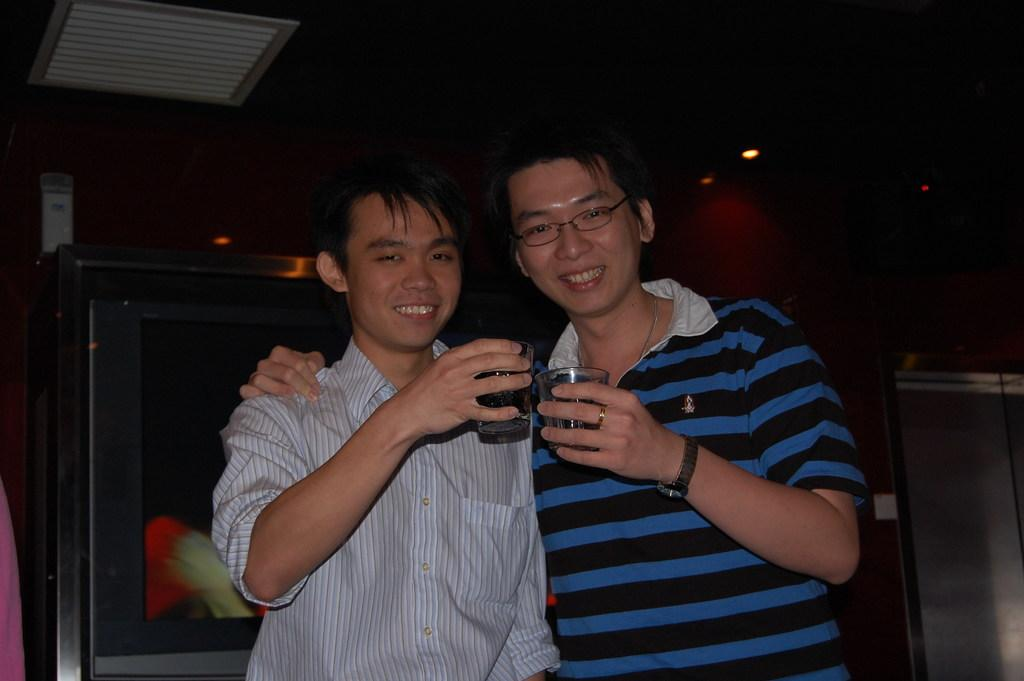How many persons are present in the image? There are two persons in the image. What are the persons wearing? The persons are wearing clothes. What are the persons holding in their hands? The persons are holding glasses with their hands. What type of care is being provided to the balls in the image? There are no balls present in the image, so it is not possible to determine if any care is being provided to them. 